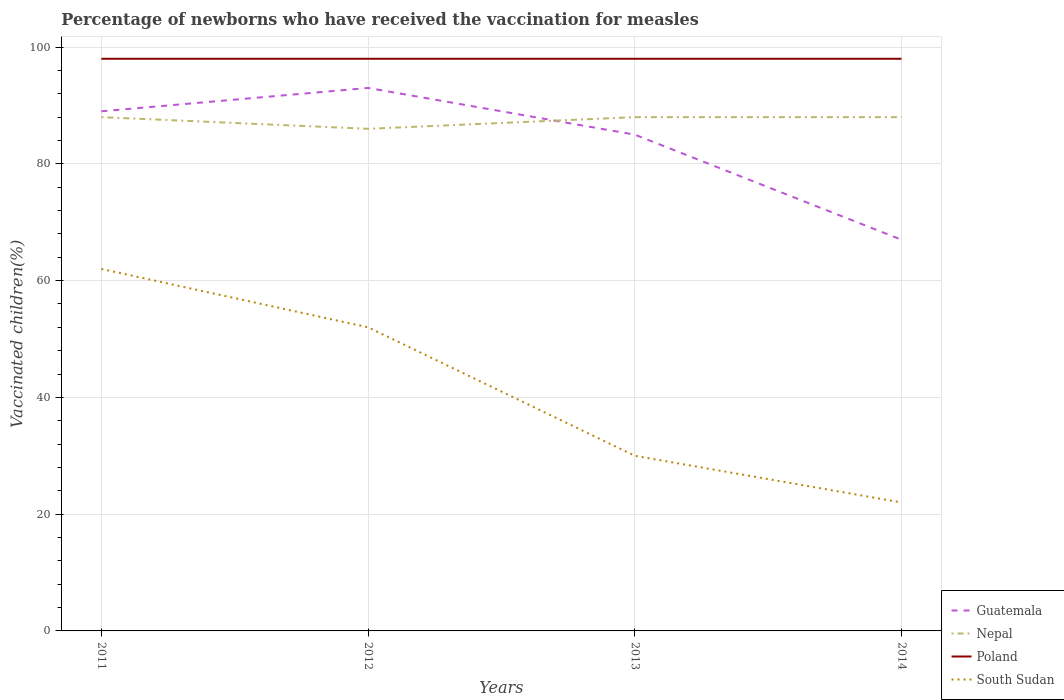How many different coloured lines are there?
Your response must be concise. 4. Does the line corresponding to Poland intersect with the line corresponding to South Sudan?
Give a very brief answer. No. Is the number of lines equal to the number of legend labels?
Offer a terse response. Yes. In which year was the percentage of vaccinated children in Poland maximum?
Give a very brief answer. 2011. What is the difference between the highest and the second highest percentage of vaccinated children in Poland?
Your answer should be compact. 0. How many years are there in the graph?
Your answer should be very brief. 4. Does the graph contain any zero values?
Give a very brief answer. No. How many legend labels are there?
Offer a very short reply. 4. What is the title of the graph?
Give a very brief answer. Percentage of newborns who have received the vaccination for measles. Does "Nicaragua" appear as one of the legend labels in the graph?
Ensure brevity in your answer.  No. What is the label or title of the Y-axis?
Your answer should be very brief. Vaccinated children(%). What is the Vaccinated children(%) of Guatemala in 2011?
Your response must be concise. 89. What is the Vaccinated children(%) in Poland in 2011?
Your response must be concise. 98. What is the Vaccinated children(%) in Guatemala in 2012?
Your answer should be compact. 93. What is the Vaccinated children(%) of Nepal in 2012?
Your answer should be compact. 86. What is the Vaccinated children(%) in Poland in 2012?
Offer a terse response. 98. What is the Vaccinated children(%) of Guatemala in 2013?
Your answer should be compact. 85. What is the Vaccinated children(%) of Nepal in 2013?
Provide a succinct answer. 88. What is the Vaccinated children(%) of Poland in 2013?
Keep it short and to the point. 98. What is the Vaccinated children(%) of Guatemala in 2014?
Make the answer very short. 67. What is the Vaccinated children(%) of Nepal in 2014?
Offer a terse response. 88. Across all years, what is the maximum Vaccinated children(%) in Guatemala?
Give a very brief answer. 93. Across all years, what is the maximum Vaccinated children(%) of Nepal?
Your answer should be compact. 88. Across all years, what is the maximum Vaccinated children(%) of South Sudan?
Keep it short and to the point. 62. Across all years, what is the minimum Vaccinated children(%) of Poland?
Provide a short and direct response. 98. What is the total Vaccinated children(%) in Guatemala in the graph?
Give a very brief answer. 334. What is the total Vaccinated children(%) in Nepal in the graph?
Provide a succinct answer. 350. What is the total Vaccinated children(%) of Poland in the graph?
Make the answer very short. 392. What is the total Vaccinated children(%) of South Sudan in the graph?
Provide a succinct answer. 166. What is the difference between the Vaccinated children(%) of Guatemala in 2011 and that in 2012?
Keep it short and to the point. -4. What is the difference between the Vaccinated children(%) of Poland in 2011 and that in 2012?
Ensure brevity in your answer.  0. What is the difference between the Vaccinated children(%) of Nepal in 2011 and that in 2013?
Give a very brief answer. 0. What is the difference between the Vaccinated children(%) in Poland in 2011 and that in 2013?
Provide a short and direct response. 0. What is the difference between the Vaccinated children(%) in South Sudan in 2011 and that in 2014?
Your answer should be very brief. 40. What is the difference between the Vaccinated children(%) in Guatemala in 2012 and that in 2013?
Make the answer very short. 8. What is the difference between the Vaccinated children(%) in Guatemala in 2012 and that in 2014?
Your answer should be compact. 26. What is the difference between the Vaccinated children(%) of Poland in 2012 and that in 2014?
Your response must be concise. 0. What is the difference between the Vaccinated children(%) in Guatemala in 2013 and that in 2014?
Provide a succinct answer. 18. What is the difference between the Vaccinated children(%) in Nepal in 2013 and that in 2014?
Keep it short and to the point. 0. What is the difference between the Vaccinated children(%) of Nepal in 2011 and the Vaccinated children(%) of South Sudan in 2012?
Offer a terse response. 36. What is the difference between the Vaccinated children(%) of Poland in 2011 and the Vaccinated children(%) of South Sudan in 2012?
Keep it short and to the point. 46. What is the difference between the Vaccinated children(%) in Guatemala in 2011 and the Vaccinated children(%) in Nepal in 2013?
Provide a short and direct response. 1. What is the difference between the Vaccinated children(%) in Guatemala in 2011 and the Vaccinated children(%) in Poland in 2013?
Ensure brevity in your answer.  -9. What is the difference between the Vaccinated children(%) of Nepal in 2011 and the Vaccinated children(%) of South Sudan in 2013?
Offer a very short reply. 58. What is the difference between the Vaccinated children(%) of Poland in 2011 and the Vaccinated children(%) of South Sudan in 2013?
Your answer should be very brief. 68. What is the difference between the Vaccinated children(%) in Guatemala in 2011 and the Vaccinated children(%) in Nepal in 2014?
Make the answer very short. 1. What is the difference between the Vaccinated children(%) of Guatemala in 2011 and the Vaccinated children(%) of Poland in 2014?
Your answer should be very brief. -9. What is the difference between the Vaccinated children(%) of Guatemala in 2011 and the Vaccinated children(%) of South Sudan in 2014?
Provide a succinct answer. 67. What is the difference between the Vaccinated children(%) of Nepal in 2011 and the Vaccinated children(%) of Poland in 2014?
Offer a terse response. -10. What is the difference between the Vaccinated children(%) of Nepal in 2011 and the Vaccinated children(%) of South Sudan in 2014?
Offer a very short reply. 66. What is the difference between the Vaccinated children(%) of Poland in 2011 and the Vaccinated children(%) of South Sudan in 2014?
Your answer should be compact. 76. What is the difference between the Vaccinated children(%) in Guatemala in 2012 and the Vaccinated children(%) in Poland in 2013?
Keep it short and to the point. -5. What is the difference between the Vaccinated children(%) in Nepal in 2012 and the Vaccinated children(%) in Poland in 2013?
Offer a terse response. -12. What is the difference between the Vaccinated children(%) of Poland in 2012 and the Vaccinated children(%) of South Sudan in 2013?
Keep it short and to the point. 68. What is the difference between the Vaccinated children(%) in Guatemala in 2012 and the Vaccinated children(%) in South Sudan in 2014?
Make the answer very short. 71. What is the difference between the Vaccinated children(%) of Guatemala in 2013 and the Vaccinated children(%) of Nepal in 2014?
Your response must be concise. -3. What is the average Vaccinated children(%) in Guatemala per year?
Give a very brief answer. 83.5. What is the average Vaccinated children(%) of Nepal per year?
Offer a terse response. 87.5. What is the average Vaccinated children(%) of South Sudan per year?
Make the answer very short. 41.5. In the year 2011, what is the difference between the Vaccinated children(%) in Guatemala and Vaccinated children(%) in Nepal?
Your answer should be compact. 1. In the year 2011, what is the difference between the Vaccinated children(%) of Guatemala and Vaccinated children(%) of South Sudan?
Offer a very short reply. 27. In the year 2011, what is the difference between the Vaccinated children(%) in Nepal and Vaccinated children(%) in Poland?
Offer a terse response. -10. In the year 2011, what is the difference between the Vaccinated children(%) of Poland and Vaccinated children(%) of South Sudan?
Your answer should be very brief. 36. In the year 2012, what is the difference between the Vaccinated children(%) in Guatemala and Vaccinated children(%) in Poland?
Keep it short and to the point. -5. In the year 2012, what is the difference between the Vaccinated children(%) in Poland and Vaccinated children(%) in South Sudan?
Ensure brevity in your answer.  46. In the year 2013, what is the difference between the Vaccinated children(%) of Nepal and Vaccinated children(%) of Poland?
Your answer should be compact. -10. In the year 2013, what is the difference between the Vaccinated children(%) of Poland and Vaccinated children(%) of South Sudan?
Give a very brief answer. 68. In the year 2014, what is the difference between the Vaccinated children(%) in Guatemala and Vaccinated children(%) in Nepal?
Offer a terse response. -21. In the year 2014, what is the difference between the Vaccinated children(%) in Guatemala and Vaccinated children(%) in Poland?
Ensure brevity in your answer.  -31. In the year 2014, what is the difference between the Vaccinated children(%) in Guatemala and Vaccinated children(%) in South Sudan?
Offer a very short reply. 45. In the year 2014, what is the difference between the Vaccinated children(%) of Nepal and Vaccinated children(%) of South Sudan?
Offer a terse response. 66. In the year 2014, what is the difference between the Vaccinated children(%) of Poland and Vaccinated children(%) of South Sudan?
Provide a short and direct response. 76. What is the ratio of the Vaccinated children(%) of Guatemala in 2011 to that in 2012?
Keep it short and to the point. 0.96. What is the ratio of the Vaccinated children(%) of Nepal in 2011 to that in 2012?
Ensure brevity in your answer.  1.02. What is the ratio of the Vaccinated children(%) of Poland in 2011 to that in 2012?
Provide a succinct answer. 1. What is the ratio of the Vaccinated children(%) in South Sudan in 2011 to that in 2012?
Your response must be concise. 1.19. What is the ratio of the Vaccinated children(%) in Guatemala in 2011 to that in 2013?
Your answer should be compact. 1.05. What is the ratio of the Vaccinated children(%) in Nepal in 2011 to that in 2013?
Your answer should be compact. 1. What is the ratio of the Vaccinated children(%) in South Sudan in 2011 to that in 2013?
Provide a short and direct response. 2.07. What is the ratio of the Vaccinated children(%) of Guatemala in 2011 to that in 2014?
Your answer should be compact. 1.33. What is the ratio of the Vaccinated children(%) in South Sudan in 2011 to that in 2014?
Make the answer very short. 2.82. What is the ratio of the Vaccinated children(%) in Guatemala in 2012 to that in 2013?
Offer a terse response. 1.09. What is the ratio of the Vaccinated children(%) of Nepal in 2012 to that in 2013?
Your answer should be very brief. 0.98. What is the ratio of the Vaccinated children(%) in South Sudan in 2012 to that in 2013?
Give a very brief answer. 1.73. What is the ratio of the Vaccinated children(%) in Guatemala in 2012 to that in 2014?
Your answer should be compact. 1.39. What is the ratio of the Vaccinated children(%) of Nepal in 2012 to that in 2014?
Give a very brief answer. 0.98. What is the ratio of the Vaccinated children(%) of Poland in 2012 to that in 2014?
Your response must be concise. 1. What is the ratio of the Vaccinated children(%) in South Sudan in 2012 to that in 2014?
Provide a short and direct response. 2.36. What is the ratio of the Vaccinated children(%) of Guatemala in 2013 to that in 2014?
Give a very brief answer. 1.27. What is the ratio of the Vaccinated children(%) in Nepal in 2013 to that in 2014?
Ensure brevity in your answer.  1. What is the ratio of the Vaccinated children(%) in South Sudan in 2013 to that in 2014?
Your answer should be very brief. 1.36. What is the difference between the highest and the second highest Vaccinated children(%) of Guatemala?
Provide a short and direct response. 4. What is the difference between the highest and the second highest Vaccinated children(%) of South Sudan?
Provide a succinct answer. 10. What is the difference between the highest and the lowest Vaccinated children(%) in Guatemala?
Your answer should be very brief. 26. What is the difference between the highest and the lowest Vaccinated children(%) of Poland?
Provide a short and direct response. 0. What is the difference between the highest and the lowest Vaccinated children(%) of South Sudan?
Make the answer very short. 40. 